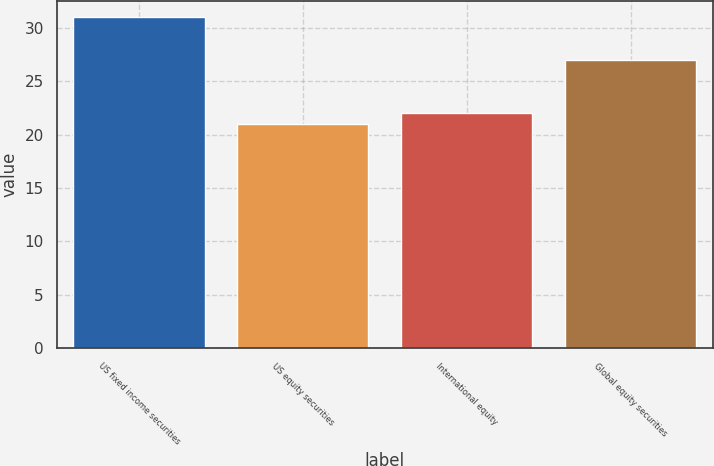<chart> <loc_0><loc_0><loc_500><loc_500><bar_chart><fcel>US fixed income securities<fcel>US equity securities<fcel>International equity<fcel>Global equity securities<nl><fcel>31<fcel>21<fcel>22<fcel>27<nl></chart> 